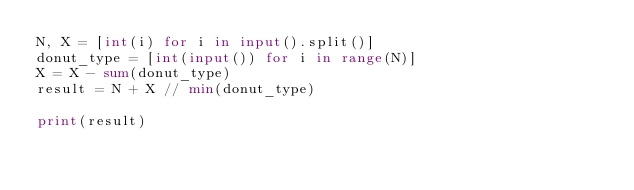Convert code to text. <code><loc_0><loc_0><loc_500><loc_500><_Python_>N, X = [int(i) for i in input().split()]
donut_type = [int(input()) for i in range(N)]
X = X - sum(donut_type)
result = N + X // min(donut_type)

print(result)</code> 